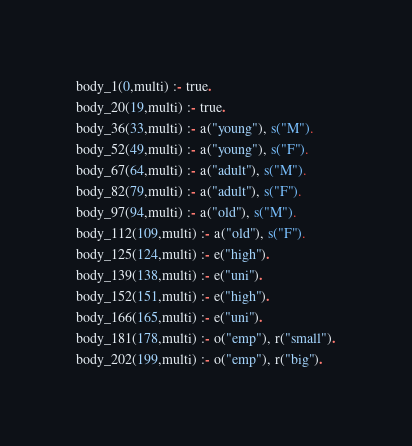Convert code to text. <code><loc_0><loc_0><loc_500><loc_500><_Perl_>body_1(0,multi) :- true.
body_20(19,multi) :- true.
body_36(33,multi) :- a("young"), s("M").
body_52(49,multi) :- a("young"), s("F").
body_67(64,multi) :- a("adult"), s("M").
body_82(79,multi) :- a("adult"), s("F").
body_97(94,multi) :- a("old"), s("M").
body_112(109,multi) :- a("old"), s("F").
body_125(124,multi) :- e("high").
body_139(138,multi) :- e("uni").
body_152(151,multi) :- e("high").
body_166(165,multi) :- e("uni").
body_181(178,multi) :- o("emp"), r("small").
body_202(199,multi) :- o("emp"), r("big").</code> 